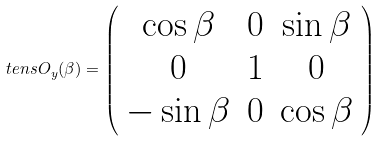<formula> <loc_0><loc_0><loc_500><loc_500>\ t e n s { O } _ { y } ( \beta ) = \left ( \begin{array} { c c c } \cos \beta & 0 & \sin \beta \\ 0 & 1 & 0 \\ - \sin \beta & 0 & \cos \beta \end{array} \right )</formula> 